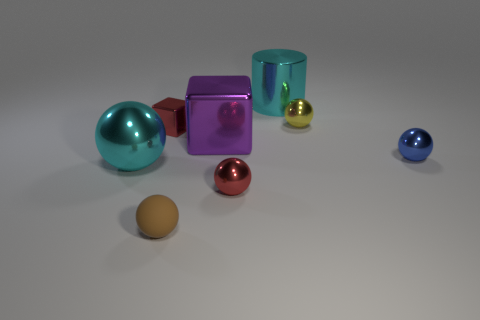Is there any other thing that is made of the same material as the small brown thing?
Keep it short and to the point. No. Do the big ball and the large cyan cylinder right of the red block have the same material?
Ensure brevity in your answer.  Yes. The cylinder has what color?
Your response must be concise. Cyan. There is a large cyan metallic object that is on the right side of the cyan metallic object in front of the yellow sphere; what number of shiny objects are left of it?
Offer a very short reply. 4. There is a big purple metallic cube; are there any blue metal things to the left of it?
Make the answer very short. No. How many tiny yellow spheres have the same material as the red sphere?
Make the answer very short. 1. How many things are blue things or cyan matte spheres?
Your answer should be very brief. 1. Are any small balls visible?
Offer a very short reply. Yes. What material is the cyan thing on the left side of the large cyan shiny thing right of the tiny object in front of the red sphere made of?
Your answer should be compact. Metal. Is the number of big metallic spheres behind the tiny red block less than the number of large brown shiny cubes?
Your answer should be compact. No. 